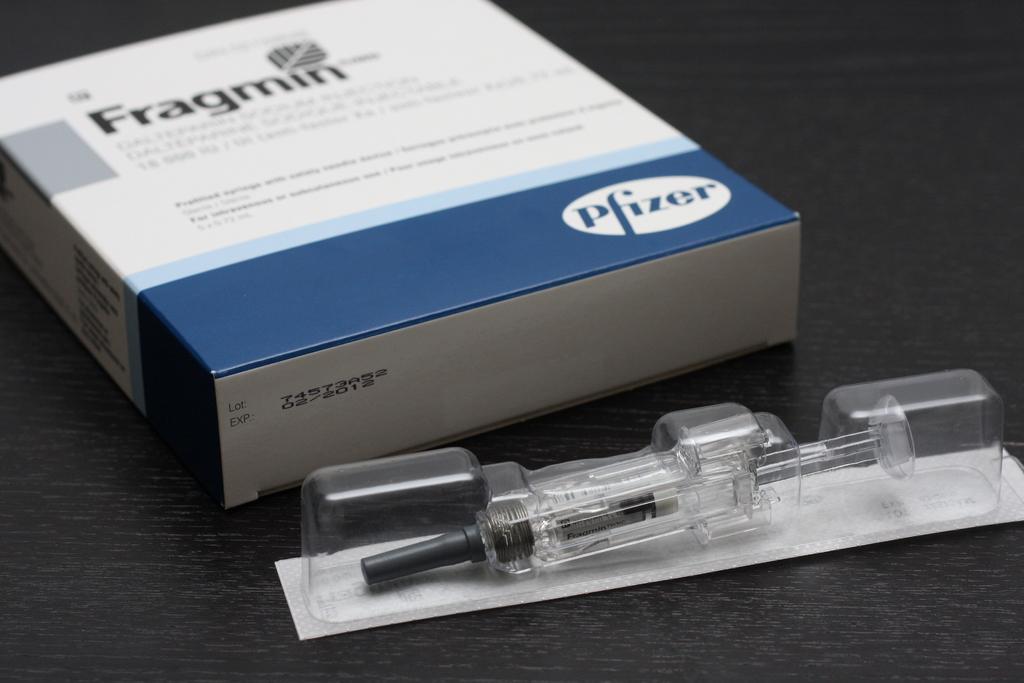What is the name of this medication?
Ensure brevity in your answer.  Fragmin. What is the company name in the bottom right corner of the box?
Make the answer very short. Pfizer. 